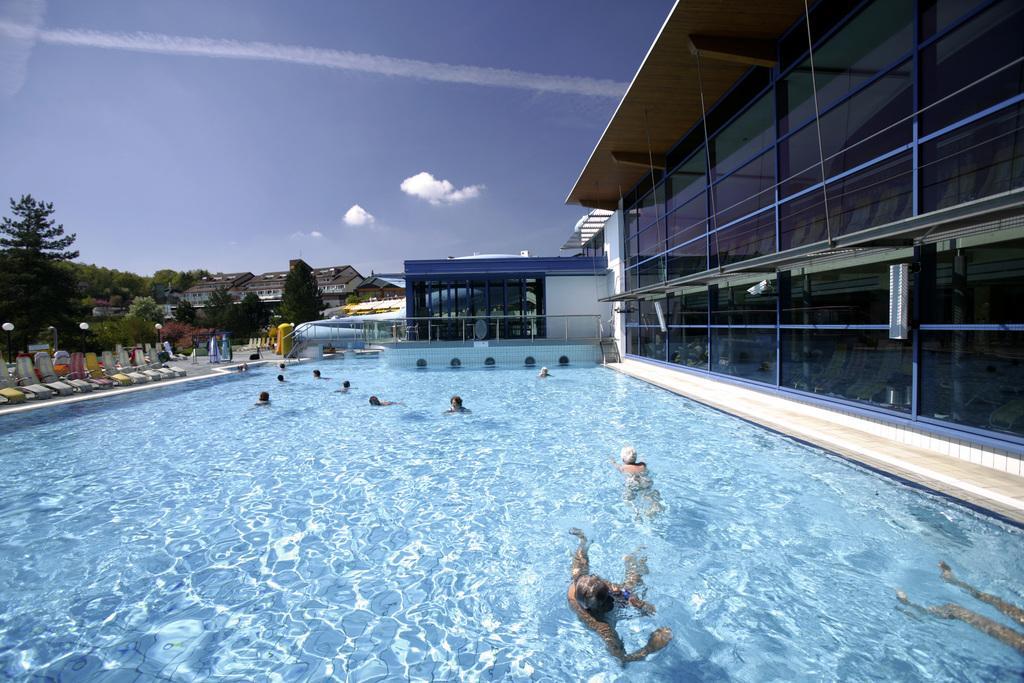In one or two sentences, can you explain what this image depicts? In this image I can see a water pool. I can see few persons in the pool. In the background I can see few buildings and trees. On the right side there is a building. At the top I can see some clouds in the sky. 